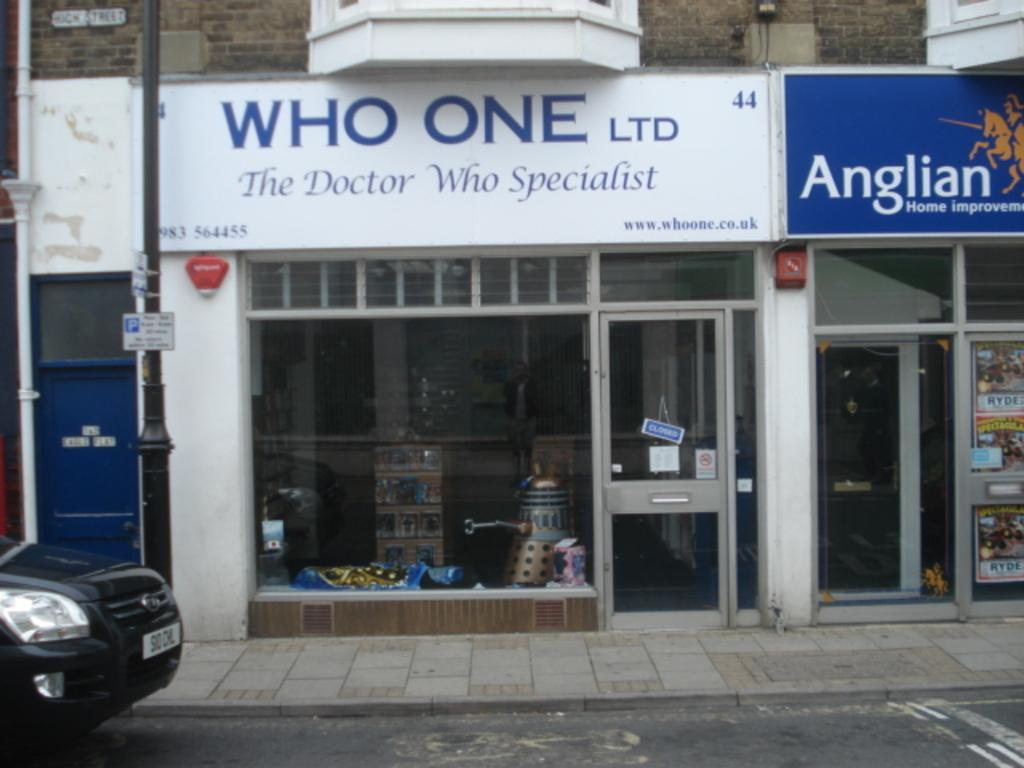What is the main subject of the image? The main subject of the image is a car. Where is the car located in the image? The car is placed side of the road. What else can be seen in the image besides the car? There are shops visible in the image. What are the boards associated with the shops used for? The boards associated with the shops are likely used for advertising or displaying information. What type of punishment is being given to the car in the image? There is no punishment being given to the car in the image; it is simply parked by the side of the road. 